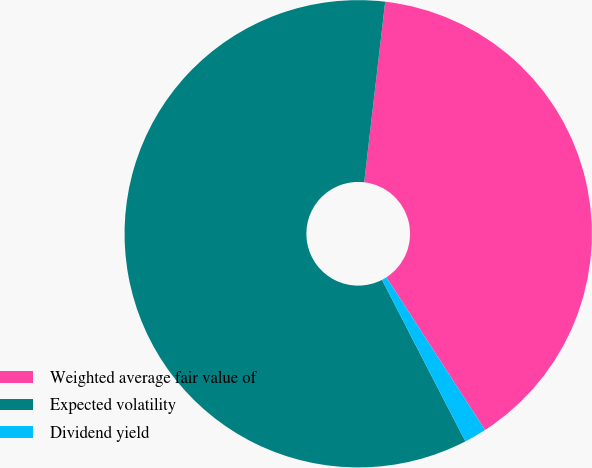Convert chart to OTSL. <chart><loc_0><loc_0><loc_500><loc_500><pie_chart><fcel>Weighted average fair value of<fcel>Expected volatility<fcel>Dividend yield<nl><fcel>39.02%<fcel>59.42%<fcel>1.55%<nl></chart> 